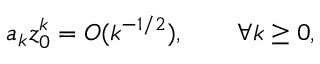<formula> <loc_0><loc_0><loc_500><loc_500>a _ { k } z _ { 0 } ^ { k } = O ( k ^ { - 1 / 2 } ) , \quad \forall k \geq 0 ,</formula> 